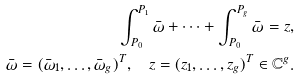<formula> <loc_0><loc_0><loc_500><loc_500>\int ^ { P _ { 1 } } _ { P _ { 0 } } \bar { \omega } + \cdots + \int ^ { P _ { g } } _ { P _ { 0 } } \bar { \omega } = z , \\ \bar { \omega } = ( \bar { \omega } _ { 1 } , \dots , \bar { \omega } _ { g } ) ^ { T } , \quad z = ( z _ { 1 } , \dots , z _ { g } ) ^ { T } \in { \mathbb { C } } ^ { g } .</formula> 